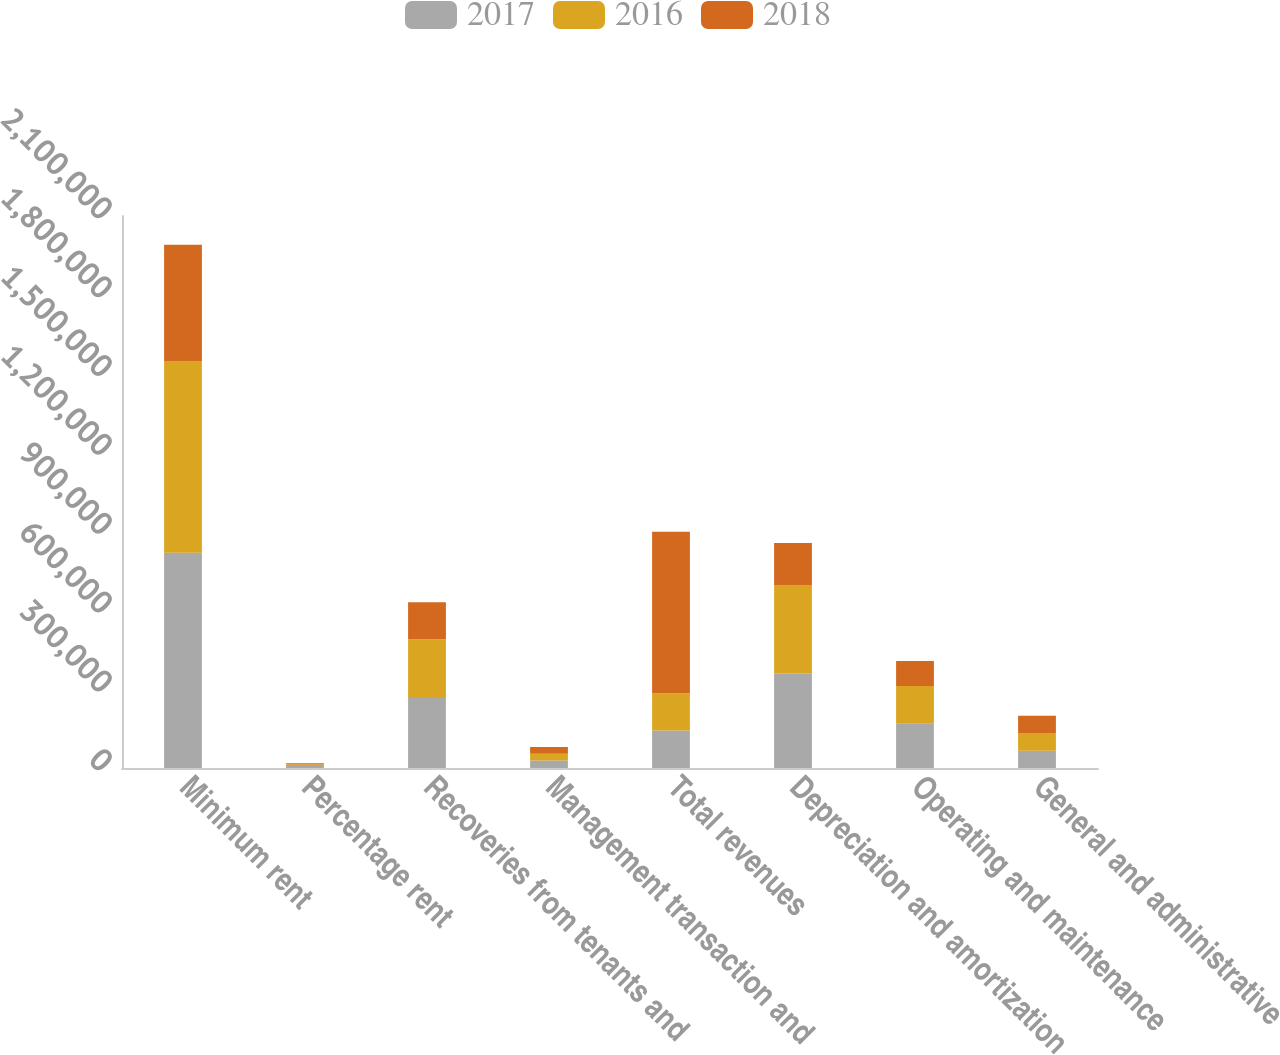Convert chart to OTSL. <chart><loc_0><loc_0><loc_500><loc_500><stacked_bar_chart><ecel><fcel>Minimum rent<fcel>Percentage rent<fcel>Recoveries from tenants and<fcel>Management transaction and<fcel>Total revenues<fcel>Depreciation and amortization<fcel>Operating and maintenance<fcel>General and administrative<nl><fcel>2017<fcel>818483<fcel>7486<fcel>266512<fcel>28494<fcel>142300<fcel>359688<fcel>168034<fcel>65491<nl><fcel>2016<fcel>728078<fcel>6635<fcel>223455<fcel>26158<fcel>142300<fcel>334201<fcel>143990<fcel>67624<nl><fcel>2018<fcel>444305<fcel>4128<fcel>140611<fcel>25327<fcel>614371<fcel>162327<fcel>95022<fcel>65327<nl></chart> 